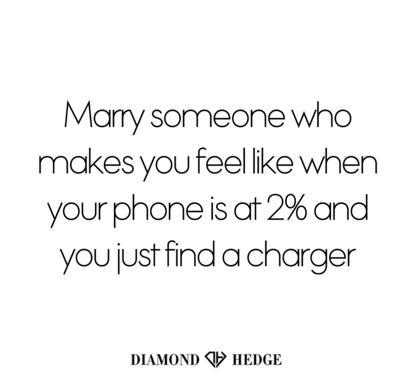How does this quote connect with modern relationship values? This quote connects deeply with modern relationship values that prioritize emotional support and security. In today's fast-paced world, having a partner who can be your 'charger'—someone who rejuvenates and stabilizes you—aligns well with the contemporary view of seeking balanced, nurturing relationships. 